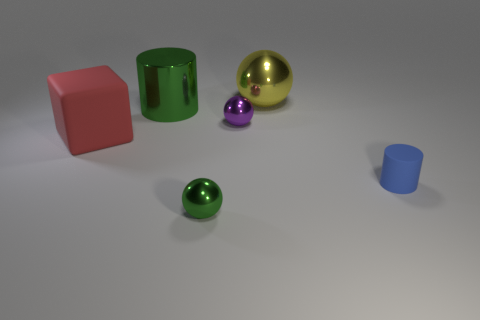Add 1 gray metal cubes. How many objects exist? 7 Subtract all cubes. How many objects are left? 5 Add 2 brown matte cubes. How many brown matte cubes exist? 2 Subtract 0 brown cylinders. How many objects are left? 6 Subtract all tiny gray shiny cubes. Subtract all red matte blocks. How many objects are left? 5 Add 1 small rubber objects. How many small rubber objects are left? 2 